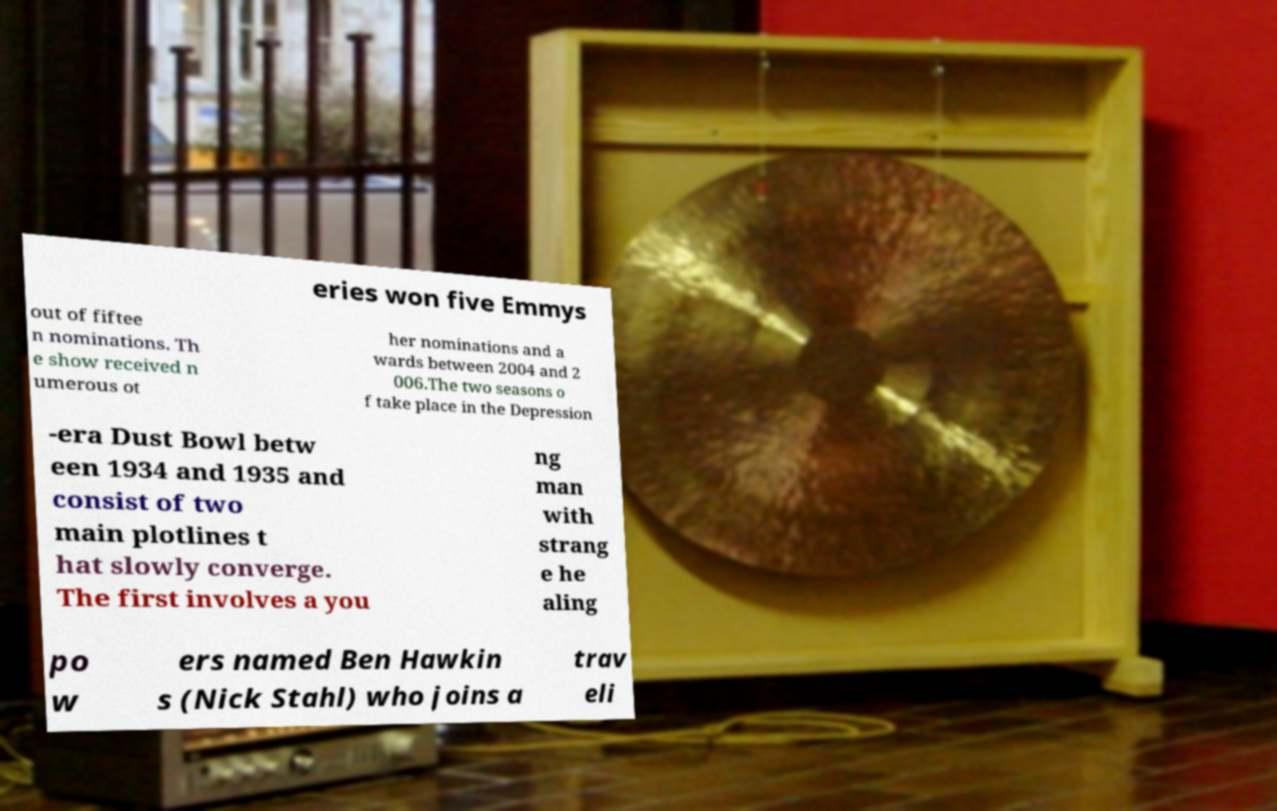Can you accurately transcribe the text from the provided image for me? eries won five Emmys out of fiftee n nominations. Th e show received n umerous ot her nominations and a wards between 2004 and 2 006.The two seasons o f take place in the Depression -era Dust Bowl betw een 1934 and 1935 and consist of two main plotlines t hat slowly converge. The first involves a you ng man with strang e he aling po w ers named Ben Hawkin s (Nick Stahl) who joins a trav eli 